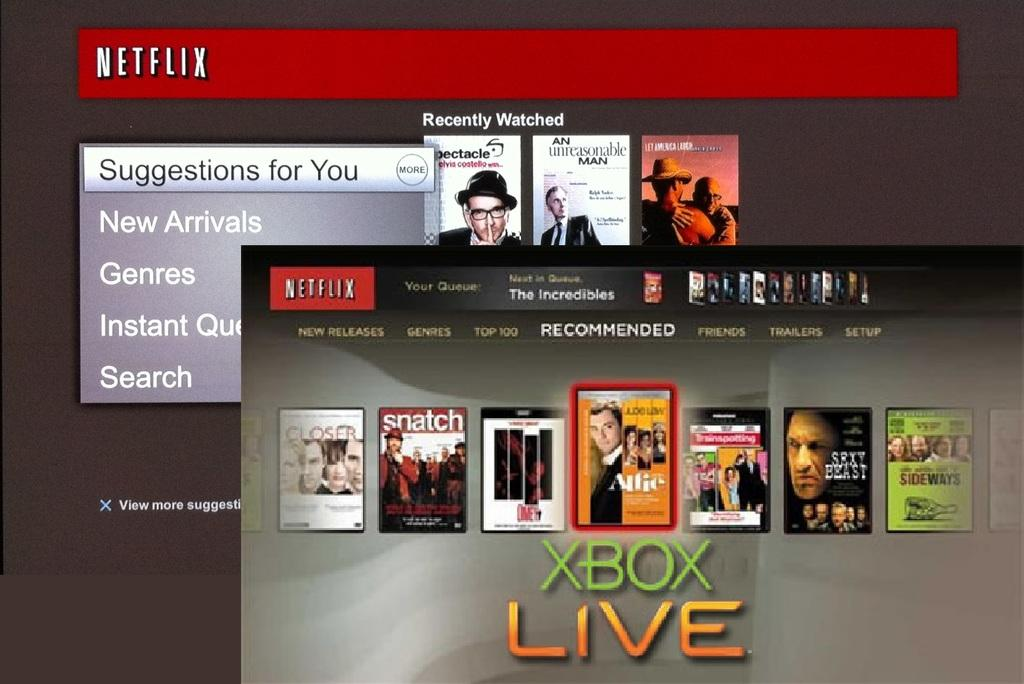<image>
Offer a succinct explanation of the picture presented. an xbox live ad that has many movies on it 